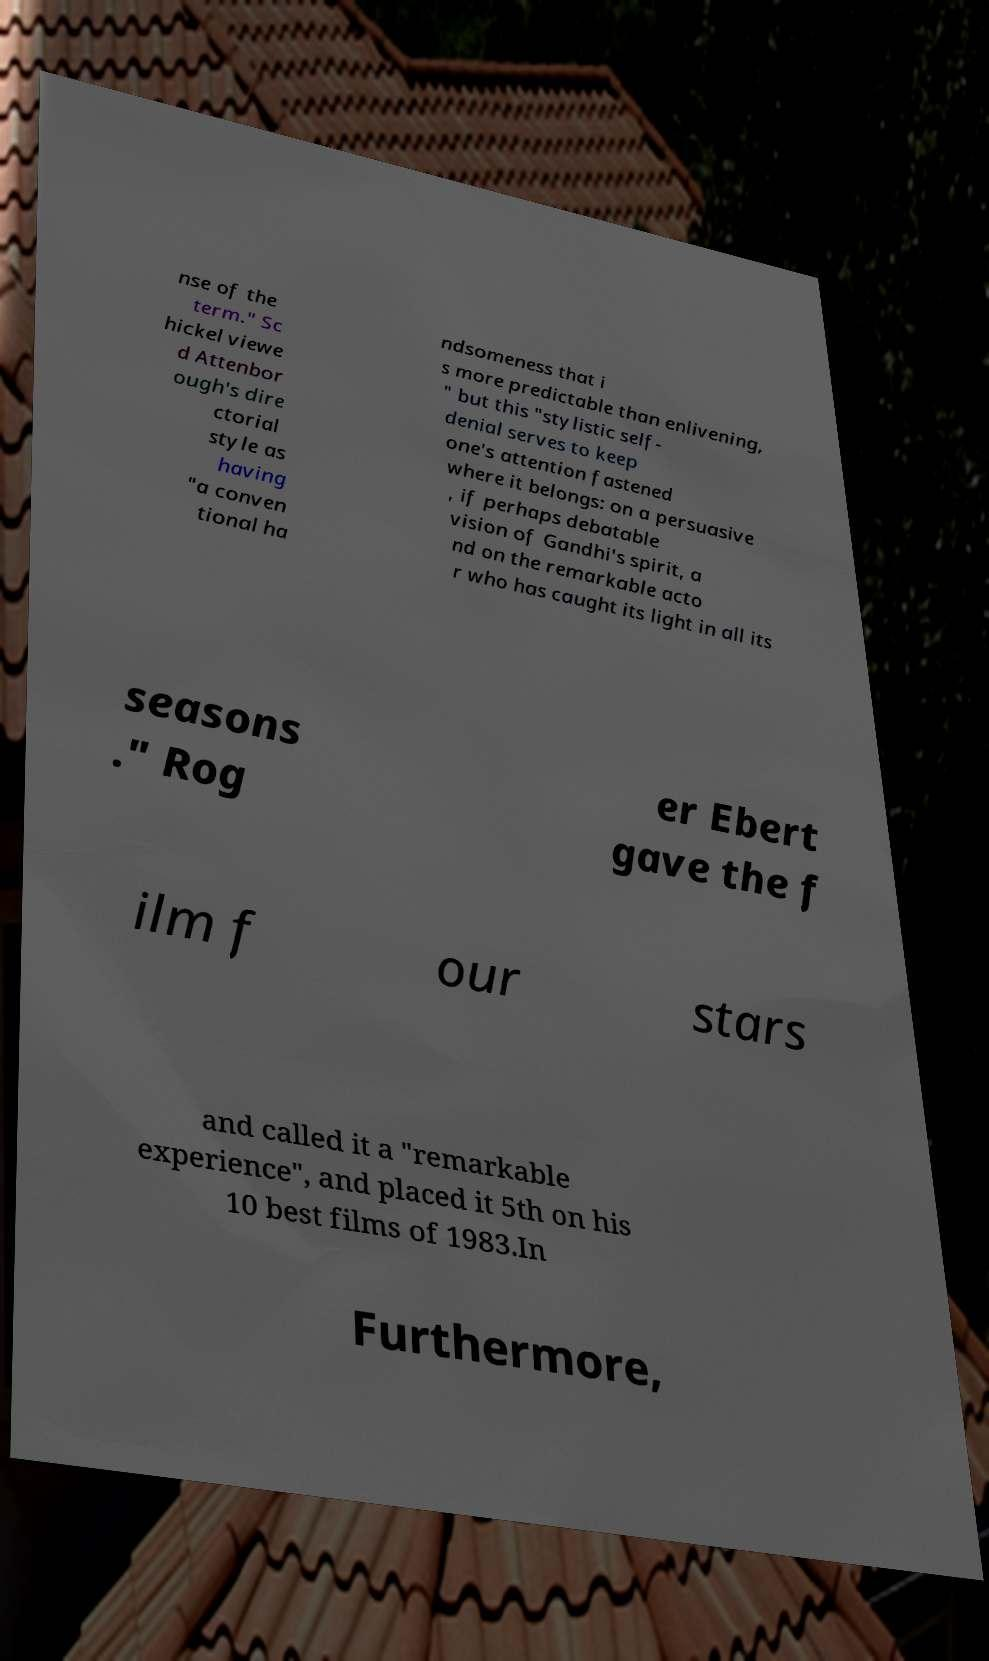For documentation purposes, I need the text within this image transcribed. Could you provide that? nse of the term." Sc hickel viewe d Attenbor ough's dire ctorial style as having "a conven tional ha ndsomeness that i s more predictable than enlivening, " but this "stylistic self- denial serves to keep one's attention fastened where it belongs: on a persuasive , if perhaps debatable vision of Gandhi's spirit, a nd on the remarkable acto r who has caught its light in all its seasons ." Rog er Ebert gave the f ilm f our stars and called it a "remarkable experience", and placed it 5th on his 10 best films of 1983.In Furthermore, 